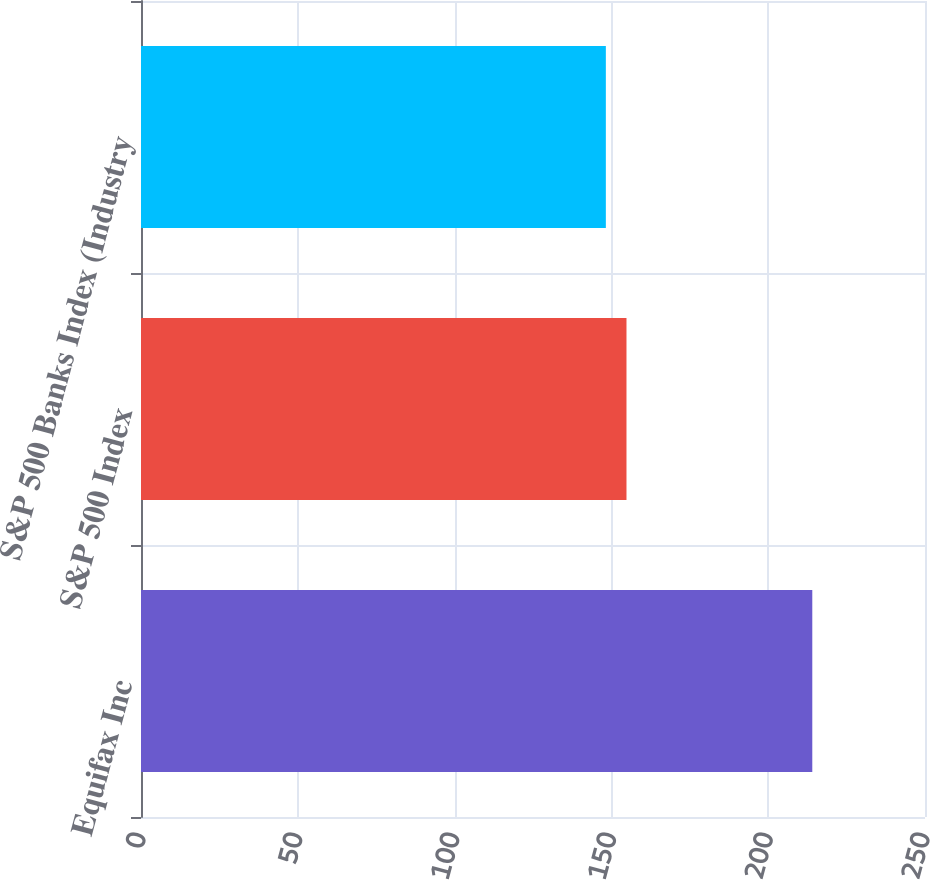<chart> <loc_0><loc_0><loc_500><loc_500><bar_chart><fcel>Equifax Inc<fcel>S&P 500 Index<fcel>S&P 500 Banks Index (Industry<nl><fcel>214.06<fcel>154.81<fcel>148.23<nl></chart> 